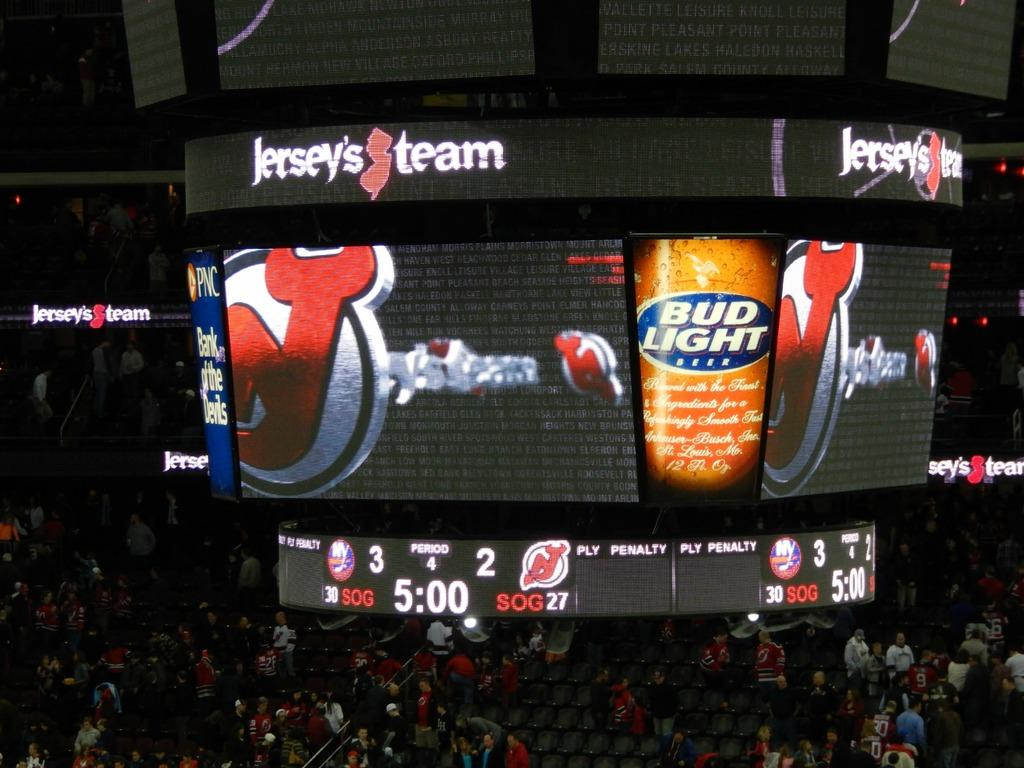Who or what can be seen in the image? There are people in the image. What are the people sitting on in the image? There are chairs in the image. What else can be seen in the image besides people and chairs? There are other objects in the image. What is being displayed on the screens in the image? There are screens displaying something in the image. Reasoning: Let'g: Let's think step by step in order to produce the conversation. We start by identifying the main subjects in the image, which are the people. Then, we describe what the people are doing or interacting with, which are the chairs. Next, we mention other objects present in the image that are not the people or chairs. Finally, we focus on the screens and what they are displaying. Absurd Question/Answer: What type of shelf can be seen holding bricks in the image? There is no shelf or bricks present in the image. How does the temper of the people in the image change throughout the scene? The provided facts do not give any information about the temper of the people in the image. What type of shelf can be seen holding bricks in the image? There is no shelf or bricks present in the image. How does the temper of the people in the image change throughout the scene? The provided facts do not give any information about the temper of the people in the image. 